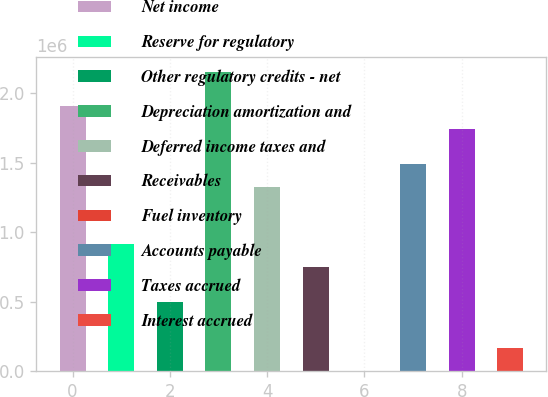<chart> <loc_0><loc_0><loc_500><loc_500><bar_chart><fcel>Net income<fcel>Reserve for regulatory<fcel>Other regulatory credits - net<fcel>Depreciation amortization and<fcel>Deferred income taxes and<fcel>Receivables<fcel>Fuel inventory<fcel>Accounts payable<fcel>Taxes accrued<fcel>Interest accrued<nl><fcel>1.90513e+06<fcel>911780<fcel>497882<fcel>2.15347e+06<fcel>1.32568e+06<fcel>746220<fcel>1205<fcel>1.49124e+06<fcel>1.73957e+06<fcel>166764<nl></chart> 